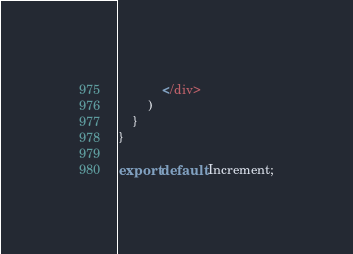<code> <loc_0><loc_0><loc_500><loc_500><_JavaScript_>            </div>
        )
    }
}

export default Increment;</code> 